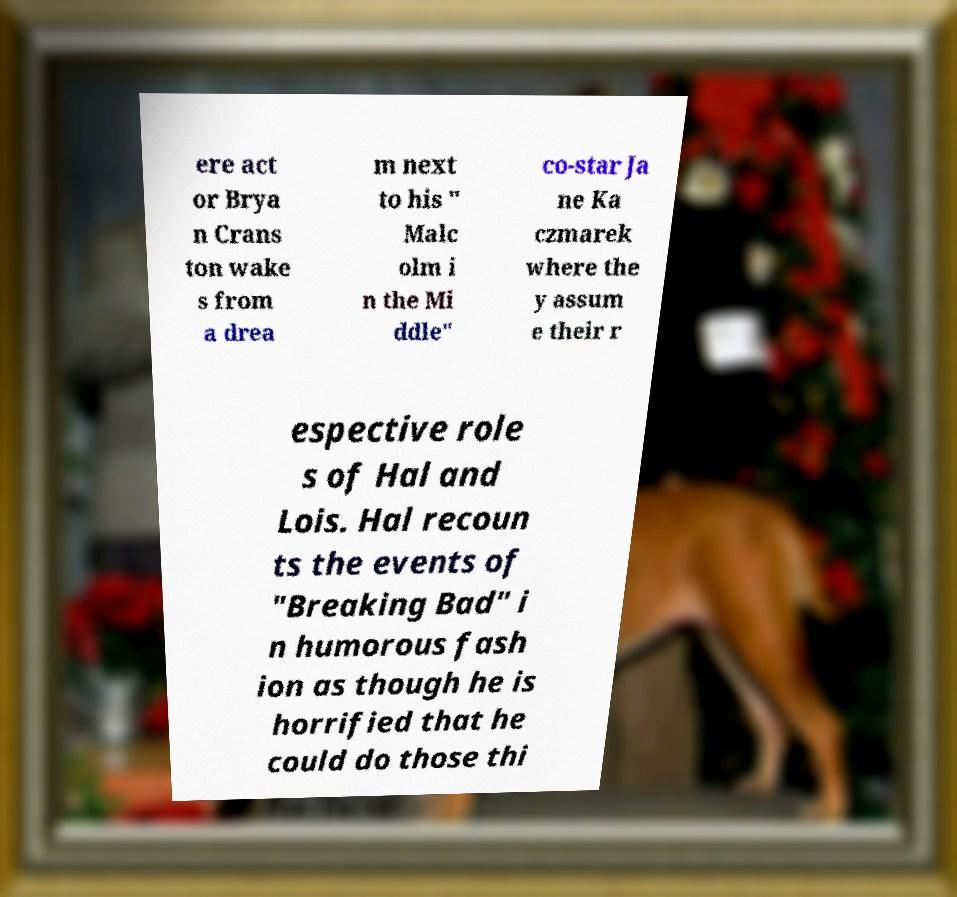I need the written content from this picture converted into text. Can you do that? ere act or Brya n Crans ton wake s from a drea m next to his " Malc olm i n the Mi ddle" co-star Ja ne Ka czmarek where the y assum e their r espective role s of Hal and Lois. Hal recoun ts the events of "Breaking Bad" i n humorous fash ion as though he is horrified that he could do those thi 